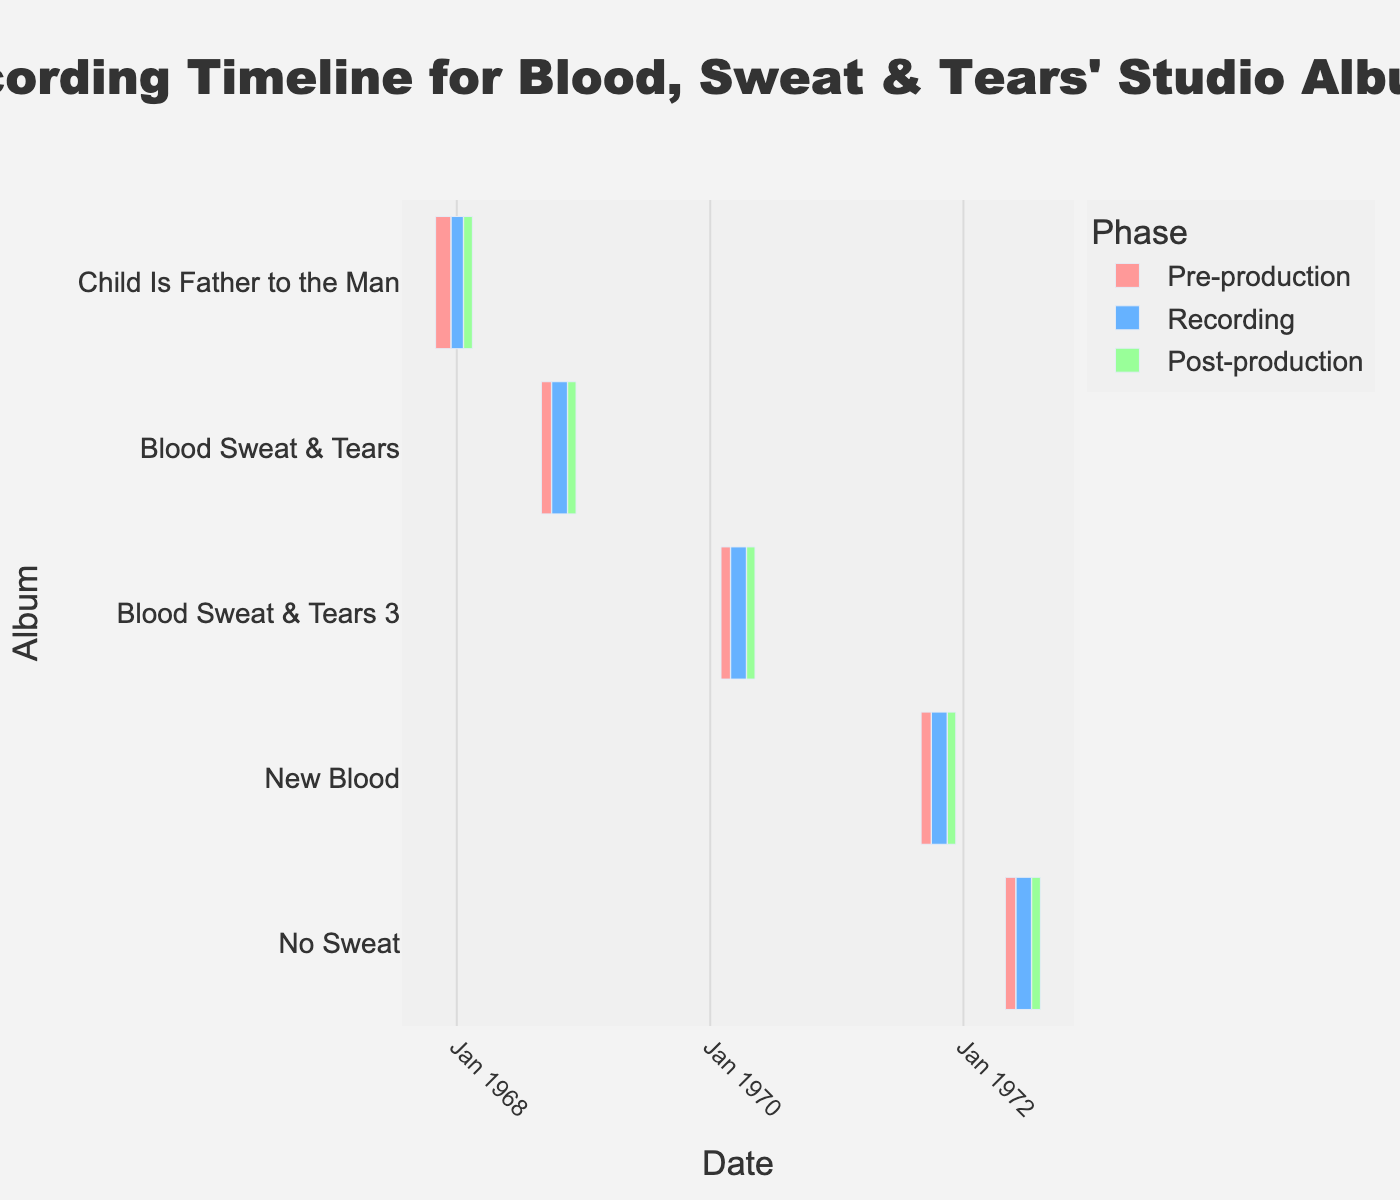What's the title of the figure? The title is located at the top center of the figure and describes the content it represents.
Answer: Recording Timeline for Blood, Sweat & Tears' Studio Albums Which album has the longest pre-production phase? By directly comparing the length of the pre-production phases indicated on the Gantt chart, "Child Is Father to the Man" has the longest pre-production phase.
Answer: Child Is Father to the Man How long did the recording phase for "Blood Sweat & Tears 3" last? The start and end dates for the recording phase of "Blood Sweat & Tears 3" are shown on the chart as March 1, 1970, to April 15, 1970. Calculating the period gives 45 days.
Answer: 45 days Compare the post-production lengths: Which album took longer in post-production, "New Blood" or "No Sweat"? Using the Gantt chart's visual data, "New Blood" post-production lasted from November 16, 1971, to December 10, 1971 (24 days), while "No Sweat" post-production lasted from July 16, 1972, to August 10, 1972 (25 days). Therefore, "No Sweat" took one day longer.
Answer: No Sweat Which album had the shortest complete production cycle (pre-production to post-production)? To find the shortest production cycle, sum the length of each phase for every album. The shortest overall duration is for "Child Is Father to the Man," from November 1, 1967, to February 15, 1968 (106 days).
Answer: Child Is Father to the Man What year and month did the recording session for "Blood Sweat & Tears" begin? The chart shows that the recording session for the "Blood Sweat & Tears" album started on October 1, 1968.
Answer: October 1968 Which phase has the most entries in the chart? By counting the number of entries for each phase (pre-production, recording, post-production), recording phases appear the most frequently.
Answer: Recording How many total days did the "New Blood" album production (all phases combined) take? Add the duration of each phase: pre-production (30 days), recording (45 days), and post-production (24 days). The total production time is 99 days.
Answer: 99 days What is the average length of the recording phases for all albums? Calculate the duration for each recording phase, sum the durations, and divide by the number of albums: (35 + 45 + 45 + 45 + 45) / 5 = 43 days on average.
Answer: 43 days 